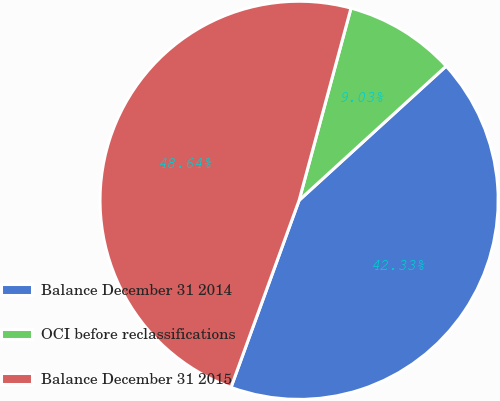Convert chart. <chart><loc_0><loc_0><loc_500><loc_500><pie_chart><fcel>Balance December 31 2014<fcel>OCI before reclassifications<fcel>Balance December 31 2015<nl><fcel>42.33%<fcel>9.03%<fcel>48.64%<nl></chart> 